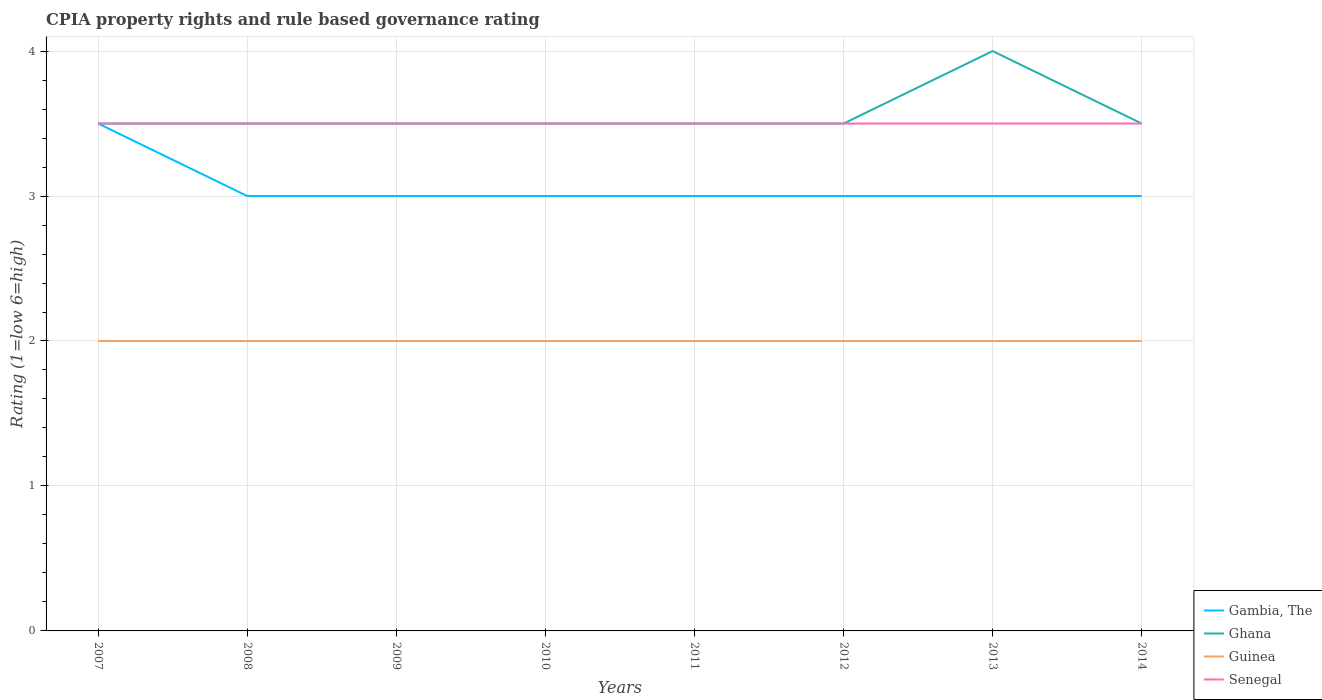How many different coloured lines are there?
Make the answer very short. 4. Is the number of lines equal to the number of legend labels?
Give a very brief answer. Yes. In which year was the CPIA rating in Ghana maximum?
Provide a short and direct response. 2007. What is the total CPIA rating in Gambia, The in the graph?
Provide a succinct answer. 0.5. What is the difference between the highest and the lowest CPIA rating in Guinea?
Offer a very short reply. 0. Is the CPIA rating in Senegal strictly greater than the CPIA rating in Ghana over the years?
Provide a short and direct response. No. How many lines are there?
Offer a terse response. 4. How many years are there in the graph?
Provide a short and direct response. 8. How are the legend labels stacked?
Provide a succinct answer. Vertical. What is the title of the graph?
Provide a succinct answer. CPIA property rights and rule based governance rating. Does "Montenegro" appear as one of the legend labels in the graph?
Offer a terse response. No. What is the label or title of the X-axis?
Your response must be concise. Years. What is the Rating (1=low 6=high) of Ghana in 2007?
Provide a short and direct response. 3.5. What is the Rating (1=low 6=high) in Guinea in 2007?
Provide a short and direct response. 2. What is the Rating (1=low 6=high) in Senegal in 2007?
Ensure brevity in your answer.  3.5. What is the Rating (1=low 6=high) of Gambia, The in 2008?
Your answer should be compact. 3. What is the Rating (1=low 6=high) of Ghana in 2008?
Your response must be concise. 3.5. What is the Rating (1=low 6=high) of Guinea in 2008?
Provide a succinct answer. 2. What is the Rating (1=low 6=high) in Gambia, The in 2009?
Your answer should be very brief. 3. What is the Rating (1=low 6=high) in Senegal in 2009?
Offer a very short reply. 3.5. What is the Rating (1=low 6=high) in Gambia, The in 2010?
Offer a terse response. 3. What is the Rating (1=low 6=high) in Guinea in 2010?
Make the answer very short. 2. What is the Rating (1=low 6=high) of Senegal in 2010?
Provide a succinct answer. 3.5. What is the Rating (1=low 6=high) of Ghana in 2011?
Your answer should be very brief. 3.5. What is the Rating (1=low 6=high) in Guinea in 2011?
Give a very brief answer. 2. What is the Rating (1=low 6=high) in Senegal in 2011?
Offer a terse response. 3.5. What is the Rating (1=low 6=high) in Gambia, The in 2012?
Offer a very short reply. 3. What is the Rating (1=low 6=high) of Senegal in 2012?
Your response must be concise. 3.5. What is the Rating (1=low 6=high) of Gambia, The in 2013?
Ensure brevity in your answer.  3. What is the Rating (1=low 6=high) in Ghana in 2014?
Ensure brevity in your answer.  3.5. Across all years, what is the maximum Rating (1=low 6=high) of Gambia, The?
Keep it short and to the point. 3.5. Across all years, what is the maximum Rating (1=low 6=high) of Ghana?
Your answer should be very brief. 4. Across all years, what is the maximum Rating (1=low 6=high) in Guinea?
Offer a very short reply. 2. Across all years, what is the minimum Rating (1=low 6=high) in Gambia, The?
Your answer should be very brief. 3. Across all years, what is the minimum Rating (1=low 6=high) of Ghana?
Give a very brief answer. 3.5. Across all years, what is the minimum Rating (1=low 6=high) in Senegal?
Your answer should be compact. 3.5. What is the total Rating (1=low 6=high) in Ghana in the graph?
Provide a short and direct response. 28.5. What is the difference between the Rating (1=low 6=high) in Ghana in 2007 and that in 2008?
Provide a succinct answer. 0. What is the difference between the Rating (1=low 6=high) in Senegal in 2007 and that in 2008?
Offer a terse response. 0. What is the difference between the Rating (1=low 6=high) in Senegal in 2007 and that in 2009?
Provide a succinct answer. 0. What is the difference between the Rating (1=low 6=high) of Gambia, The in 2007 and that in 2010?
Provide a short and direct response. 0.5. What is the difference between the Rating (1=low 6=high) of Guinea in 2007 and that in 2010?
Keep it short and to the point. 0. What is the difference between the Rating (1=low 6=high) of Guinea in 2007 and that in 2011?
Your answer should be very brief. 0. What is the difference between the Rating (1=low 6=high) in Gambia, The in 2007 and that in 2012?
Your answer should be compact. 0.5. What is the difference between the Rating (1=low 6=high) in Ghana in 2007 and that in 2012?
Provide a short and direct response. 0. What is the difference between the Rating (1=low 6=high) in Senegal in 2007 and that in 2012?
Make the answer very short. 0. What is the difference between the Rating (1=low 6=high) of Gambia, The in 2007 and that in 2013?
Give a very brief answer. 0.5. What is the difference between the Rating (1=low 6=high) in Guinea in 2007 and that in 2013?
Give a very brief answer. 0. What is the difference between the Rating (1=low 6=high) in Guinea in 2007 and that in 2014?
Provide a short and direct response. 0. What is the difference between the Rating (1=low 6=high) in Gambia, The in 2008 and that in 2011?
Offer a terse response. 0. What is the difference between the Rating (1=low 6=high) in Guinea in 2008 and that in 2011?
Provide a short and direct response. 0. What is the difference between the Rating (1=low 6=high) in Gambia, The in 2008 and that in 2013?
Keep it short and to the point. 0. What is the difference between the Rating (1=low 6=high) of Ghana in 2008 and that in 2013?
Your answer should be very brief. -0.5. What is the difference between the Rating (1=low 6=high) in Ghana in 2008 and that in 2014?
Offer a very short reply. 0. What is the difference between the Rating (1=low 6=high) of Senegal in 2008 and that in 2014?
Make the answer very short. 0. What is the difference between the Rating (1=low 6=high) of Senegal in 2009 and that in 2010?
Make the answer very short. 0. What is the difference between the Rating (1=low 6=high) of Gambia, The in 2009 and that in 2011?
Your response must be concise. 0. What is the difference between the Rating (1=low 6=high) in Guinea in 2009 and that in 2011?
Your response must be concise. 0. What is the difference between the Rating (1=low 6=high) of Senegal in 2009 and that in 2011?
Give a very brief answer. 0. What is the difference between the Rating (1=low 6=high) of Ghana in 2009 and that in 2012?
Offer a very short reply. 0. What is the difference between the Rating (1=low 6=high) in Guinea in 2009 and that in 2012?
Your response must be concise. 0. What is the difference between the Rating (1=low 6=high) of Senegal in 2009 and that in 2012?
Make the answer very short. 0. What is the difference between the Rating (1=low 6=high) of Ghana in 2009 and that in 2013?
Ensure brevity in your answer.  -0.5. What is the difference between the Rating (1=low 6=high) in Guinea in 2009 and that in 2013?
Your answer should be compact. 0. What is the difference between the Rating (1=low 6=high) in Gambia, The in 2009 and that in 2014?
Your answer should be very brief. 0. What is the difference between the Rating (1=low 6=high) of Ghana in 2009 and that in 2014?
Give a very brief answer. 0. What is the difference between the Rating (1=low 6=high) of Guinea in 2009 and that in 2014?
Make the answer very short. 0. What is the difference between the Rating (1=low 6=high) of Ghana in 2010 and that in 2011?
Provide a short and direct response. 0. What is the difference between the Rating (1=low 6=high) of Guinea in 2010 and that in 2011?
Your answer should be compact. 0. What is the difference between the Rating (1=low 6=high) of Gambia, The in 2010 and that in 2012?
Provide a succinct answer. 0. What is the difference between the Rating (1=low 6=high) of Gambia, The in 2010 and that in 2013?
Give a very brief answer. 0. What is the difference between the Rating (1=low 6=high) in Ghana in 2010 and that in 2014?
Your answer should be compact. 0. What is the difference between the Rating (1=low 6=high) of Gambia, The in 2011 and that in 2012?
Provide a succinct answer. 0. What is the difference between the Rating (1=low 6=high) of Ghana in 2011 and that in 2012?
Your answer should be compact. 0. What is the difference between the Rating (1=low 6=high) of Senegal in 2011 and that in 2012?
Offer a terse response. 0. What is the difference between the Rating (1=low 6=high) in Ghana in 2011 and that in 2013?
Provide a succinct answer. -0.5. What is the difference between the Rating (1=low 6=high) of Guinea in 2011 and that in 2013?
Offer a very short reply. 0. What is the difference between the Rating (1=low 6=high) of Ghana in 2011 and that in 2014?
Give a very brief answer. 0. What is the difference between the Rating (1=low 6=high) of Senegal in 2011 and that in 2014?
Offer a very short reply. 0. What is the difference between the Rating (1=low 6=high) of Ghana in 2012 and that in 2013?
Your response must be concise. -0.5. What is the difference between the Rating (1=low 6=high) of Guinea in 2012 and that in 2013?
Provide a short and direct response. 0. What is the difference between the Rating (1=low 6=high) in Gambia, The in 2012 and that in 2014?
Provide a succinct answer. 0. What is the difference between the Rating (1=low 6=high) of Ghana in 2012 and that in 2014?
Your answer should be compact. 0. What is the difference between the Rating (1=low 6=high) in Senegal in 2012 and that in 2014?
Give a very brief answer. 0. What is the difference between the Rating (1=low 6=high) of Ghana in 2013 and that in 2014?
Offer a very short reply. 0.5. What is the difference between the Rating (1=low 6=high) of Guinea in 2013 and that in 2014?
Your answer should be very brief. 0. What is the difference between the Rating (1=low 6=high) of Gambia, The in 2007 and the Rating (1=low 6=high) of Ghana in 2008?
Give a very brief answer. 0. What is the difference between the Rating (1=low 6=high) in Gambia, The in 2007 and the Rating (1=low 6=high) in Guinea in 2008?
Give a very brief answer. 1.5. What is the difference between the Rating (1=low 6=high) of Ghana in 2007 and the Rating (1=low 6=high) of Guinea in 2008?
Give a very brief answer. 1.5. What is the difference between the Rating (1=low 6=high) in Ghana in 2007 and the Rating (1=low 6=high) in Senegal in 2008?
Offer a very short reply. 0. What is the difference between the Rating (1=low 6=high) in Guinea in 2007 and the Rating (1=low 6=high) in Senegal in 2008?
Provide a succinct answer. -1.5. What is the difference between the Rating (1=low 6=high) in Gambia, The in 2007 and the Rating (1=low 6=high) in Guinea in 2009?
Ensure brevity in your answer.  1.5. What is the difference between the Rating (1=low 6=high) in Ghana in 2007 and the Rating (1=low 6=high) in Guinea in 2009?
Make the answer very short. 1.5. What is the difference between the Rating (1=low 6=high) in Guinea in 2007 and the Rating (1=low 6=high) in Senegal in 2009?
Provide a short and direct response. -1.5. What is the difference between the Rating (1=low 6=high) in Gambia, The in 2007 and the Rating (1=low 6=high) in Ghana in 2010?
Your answer should be compact. 0. What is the difference between the Rating (1=low 6=high) of Gambia, The in 2007 and the Rating (1=low 6=high) of Senegal in 2010?
Give a very brief answer. 0. What is the difference between the Rating (1=low 6=high) of Ghana in 2007 and the Rating (1=low 6=high) of Senegal in 2010?
Make the answer very short. 0. What is the difference between the Rating (1=low 6=high) in Gambia, The in 2007 and the Rating (1=low 6=high) in Guinea in 2011?
Provide a succinct answer. 1.5. What is the difference between the Rating (1=low 6=high) in Ghana in 2007 and the Rating (1=low 6=high) in Guinea in 2011?
Offer a terse response. 1.5. What is the difference between the Rating (1=low 6=high) of Ghana in 2007 and the Rating (1=low 6=high) of Senegal in 2012?
Give a very brief answer. 0. What is the difference between the Rating (1=low 6=high) in Gambia, The in 2007 and the Rating (1=low 6=high) in Ghana in 2013?
Offer a terse response. -0.5. What is the difference between the Rating (1=low 6=high) of Gambia, The in 2007 and the Rating (1=low 6=high) of Guinea in 2013?
Your response must be concise. 1.5. What is the difference between the Rating (1=low 6=high) of Gambia, The in 2007 and the Rating (1=low 6=high) of Senegal in 2013?
Offer a very short reply. 0. What is the difference between the Rating (1=low 6=high) in Ghana in 2007 and the Rating (1=low 6=high) in Senegal in 2013?
Give a very brief answer. 0. What is the difference between the Rating (1=low 6=high) of Guinea in 2007 and the Rating (1=low 6=high) of Senegal in 2013?
Provide a succinct answer. -1.5. What is the difference between the Rating (1=low 6=high) of Gambia, The in 2007 and the Rating (1=low 6=high) of Ghana in 2014?
Offer a terse response. 0. What is the difference between the Rating (1=low 6=high) of Gambia, The in 2007 and the Rating (1=low 6=high) of Senegal in 2014?
Make the answer very short. 0. What is the difference between the Rating (1=low 6=high) in Ghana in 2007 and the Rating (1=low 6=high) in Senegal in 2014?
Your response must be concise. 0. What is the difference between the Rating (1=low 6=high) in Gambia, The in 2008 and the Rating (1=low 6=high) in Guinea in 2009?
Your answer should be very brief. 1. What is the difference between the Rating (1=low 6=high) in Ghana in 2008 and the Rating (1=low 6=high) in Guinea in 2009?
Provide a succinct answer. 1.5. What is the difference between the Rating (1=low 6=high) in Guinea in 2008 and the Rating (1=low 6=high) in Senegal in 2009?
Make the answer very short. -1.5. What is the difference between the Rating (1=low 6=high) in Gambia, The in 2008 and the Rating (1=low 6=high) in Guinea in 2010?
Ensure brevity in your answer.  1. What is the difference between the Rating (1=low 6=high) in Gambia, The in 2008 and the Rating (1=low 6=high) in Senegal in 2010?
Give a very brief answer. -0.5. What is the difference between the Rating (1=low 6=high) in Ghana in 2008 and the Rating (1=low 6=high) in Senegal in 2010?
Make the answer very short. 0. What is the difference between the Rating (1=low 6=high) of Guinea in 2008 and the Rating (1=low 6=high) of Senegal in 2010?
Make the answer very short. -1.5. What is the difference between the Rating (1=low 6=high) of Gambia, The in 2008 and the Rating (1=low 6=high) of Ghana in 2011?
Provide a short and direct response. -0.5. What is the difference between the Rating (1=low 6=high) in Gambia, The in 2008 and the Rating (1=low 6=high) in Guinea in 2011?
Give a very brief answer. 1. What is the difference between the Rating (1=low 6=high) of Guinea in 2008 and the Rating (1=low 6=high) of Senegal in 2011?
Make the answer very short. -1.5. What is the difference between the Rating (1=low 6=high) in Gambia, The in 2008 and the Rating (1=low 6=high) in Ghana in 2012?
Your answer should be compact. -0.5. What is the difference between the Rating (1=low 6=high) of Ghana in 2008 and the Rating (1=low 6=high) of Guinea in 2012?
Keep it short and to the point. 1.5. What is the difference between the Rating (1=low 6=high) of Gambia, The in 2008 and the Rating (1=low 6=high) of Ghana in 2013?
Give a very brief answer. -1. What is the difference between the Rating (1=low 6=high) in Gambia, The in 2008 and the Rating (1=low 6=high) in Senegal in 2013?
Ensure brevity in your answer.  -0.5. What is the difference between the Rating (1=low 6=high) of Gambia, The in 2008 and the Rating (1=low 6=high) of Guinea in 2014?
Your response must be concise. 1. What is the difference between the Rating (1=low 6=high) of Gambia, The in 2008 and the Rating (1=low 6=high) of Senegal in 2014?
Your response must be concise. -0.5. What is the difference between the Rating (1=low 6=high) in Ghana in 2008 and the Rating (1=low 6=high) in Senegal in 2014?
Provide a succinct answer. 0. What is the difference between the Rating (1=low 6=high) of Gambia, The in 2009 and the Rating (1=low 6=high) of Ghana in 2010?
Your answer should be very brief. -0.5. What is the difference between the Rating (1=low 6=high) of Gambia, The in 2009 and the Rating (1=low 6=high) of Senegal in 2010?
Your answer should be very brief. -0.5. What is the difference between the Rating (1=low 6=high) of Gambia, The in 2009 and the Rating (1=low 6=high) of Ghana in 2011?
Give a very brief answer. -0.5. What is the difference between the Rating (1=low 6=high) of Gambia, The in 2009 and the Rating (1=low 6=high) of Guinea in 2011?
Offer a terse response. 1. What is the difference between the Rating (1=low 6=high) of Ghana in 2009 and the Rating (1=low 6=high) of Guinea in 2011?
Your answer should be very brief. 1.5. What is the difference between the Rating (1=low 6=high) in Ghana in 2009 and the Rating (1=low 6=high) in Senegal in 2011?
Make the answer very short. 0. What is the difference between the Rating (1=low 6=high) in Gambia, The in 2009 and the Rating (1=low 6=high) in Ghana in 2012?
Offer a terse response. -0.5. What is the difference between the Rating (1=low 6=high) of Gambia, The in 2009 and the Rating (1=low 6=high) of Guinea in 2012?
Provide a succinct answer. 1. What is the difference between the Rating (1=low 6=high) of Gambia, The in 2009 and the Rating (1=low 6=high) of Senegal in 2012?
Your answer should be very brief. -0.5. What is the difference between the Rating (1=low 6=high) in Ghana in 2009 and the Rating (1=low 6=high) in Guinea in 2012?
Provide a succinct answer. 1.5. What is the difference between the Rating (1=low 6=high) of Ghana in 2009 and the Rating (1=low 6=high) of Senegal in 2012?
Provide a short and direct response. 0. What is the difference between the Rating (1=low 6=high) in Guinea in 2009 and the Rating (1=low 6=high) in Senegal in 2012?
Offer a terse response. -1.5. What is the difference between the Rating (1=low 6=high) in Ghana in 2009 and the Rating (1=low 6=high) in Senegal in 2013?
Provide a short and direct response. 0. What is the difference between the Rating (1=low 6=high) of Guinea in 2009 and the Rating (1=low 6=high) of Senegal in 2013?
Your answer should be compact. -1.5. What is the difference between the Rating (1=low 6=high) in Gambia, The in 2009 and the Rating (1=low 6=high) in Ghana in 2014?
Provide a short and direct response. -0.5. What is the difference between the Rating (1=low 6=high) of Gambia, The in 2009 and the Rating (1=low 6=high) of Guinea in 2014?
Keep it short and to the point. 1. What is the difference between the Rating (1=low 6=high) in Ghana in 2009 and the Rating (1=low 6=high) in Guinea in 2014?
Give a very brief answer. 1.5. What is the difference between the Rating (1=low 6=high) in Ghana in 2009 and the Rating (1=low 6=high) in Senegal in 2014?
Offer a terse response. 0. What is the difference between the Rating (1=low 6=high) of Guinea in 2009 and the Rating (1=low 6=high) of Senegal in 2014?
Your answer should be very brief. -1.5. What is the difference between the Rating (1=low 6=high) of Gambia, The in 2010 and the Rating (1=low 6=high) of Senegal in 2011?
Your answer should be very brief. -0.5. What is the difference between the Rating (1=low 6=high) in Guinea in 2010 and the Rating (1=low 6=high) in Senegal in 2012?
Give a very brief answer. -1.5. What is the difference between the Rating (1=low 6=high) of Gambia, The in 2010 and the Rating (1=low 6=high) of Guinea in 2013?
Your answer should be very brief. 1. What is the difference between the Rating (1=low 6=high) of Gambia, The in 2010 and the Rating (1=low 6=high) of Senegal in 2013?
Provide a succinct answer. -0.5. What is the difference between the Rating (1=low 6=high) of Ghana in 2010 and the Rating (1=low 6=high) of Guinea in 2013?
Make the answer very short. 1.5. What is the difference between the Rating (1=low 6=high) in Guinea in 2010 and the Rating (1=low 6=high) in Senegal in 2013?
Your answer should be compact. -1.5. What is the difference between the Rating (1=low 6=high) of Gambia, The in 2010 and the Rating (1=low 6=high) of Guinea in 2014?
Provide a succinct answer. 1. What is the difference between the Rating (1=low 6=high) of Ghana in 2010 and the Rating (1=low 6=high) of Guinea in 2014?
Give a very brief answer. 1.5. What is the difference between the Rating (1=low 6=high) of Guinea in 2010 and the Rating (1=low 6=high) of Senegal in 2014?
Provide a succinct answer. -1.5. What is the difference between the Rating (1=low 6=high) in Gambia, The in 2011 and the Rating (1=low 6=high) in Ghana in 2012?
Offer a very short reply. -0.5. What is the difference between the Rating (1=low 6=high) of Gambia, The in 2011 and the Rating (1=low 6=high) of Guinea in 2012?
Offer a very short reply. 1. What is the difference between the Rating (1=low 6=high) of Gambia, The in 2011 and the Rating (1=low 6=high) of Senegal in 2012?
Provide a succinct answer. -0.5. What is the difference between the Rating (1=low 6=high) in Ghana in 2011 and the Rating (1=low 6=high) in Senegal in 2012?
Offer a very short reply. 0. What is the difference between the Rating (1=low 6=high) in Guinea in 2011 and the Rating (1=low 6=high) in Senegal in 2012?
Ensure brevity in your answer.  -1.5. What is the difference between the Rating (1=low 6=high) in Gambia, The in 2011 and the Rating (1=low 6=high) in Guinea in 2013?
Provide a short and direct response. 1. What is the difference between the Rating (1=low 6=high) of Gambia, The in 2011 and the Rating (1=low 6=high) of Senegal in 2013?
Ensure brevity in your answer.  -0.5. What is the difference between the Rating (1=low 6=high) of Ghana in 2011 and the Rating (1=low 6=high) of Senegal in 2013?
Provide a short and direct response. 0. What is the difference between the Rating (1=low 6=high) in Guinea in 2011 and the Rating (1=low 6=high) in Senegal in 2013?
Offer a very short reply. -1.5. What is the difference between the Rating (1=low 6=high) of Gambia, The in 2011 and the Rating (1=low 6=high) of Ghana in 2014?
Make the answer very short. -0.5. What is the difference between the Rating (1=low 6=high) of Gambia, The in 2011 and the Rating (1=low 6=high) of Guinea in 2014?
Offer a terse response. 1. What is the difference between the Rating (1=low 6=high) in Guinea in 2011 and the Rating (1=low 6=high) in Senegal in 2014?
Your answer should be very brief. -1.5. What is the difference between the Rating (1=low 6=high) of Gambia, The in 2012 and the Rating (1=low 6=high) of Ghana in 2013?
Provide a short and direct response. -1. What is the difference between the Rating (1=low 6=high) of Gambia, The in 2012 and the Rating (1=low 6=high) of Guinea in 2013?
Provide a succinct answer. 1. What is the difference between the Rating (1=low 6=high) of Ghana in 2012 and the Rating (1=low 6=high) of Senegal in 2013?
Keep it short and to the point. 0. What is the difference between the Rating (1=low 6=high) of Guinea in 2012 and the Rating (1=low 6=high) of Senegal in 2013?
Your response must be concise. -1.5. What is the difference between the Rating (1=low 6=high) of Gambia, The in 2012 and the Rating (1=low 6=high) of Ghana in 2014?
Your response must be concise. -0.5. What is the difference between the Rating (1=low 6=high) of Gambia, The in 2012 and the Rating (1=low 6=high) of Senegal in 2014?
Provide a short and direct response. -0.5. What is the difference between the Rating (1=low 6=high) of Ghana in 2012 and the Rating (1=low 6=high) of Guinea in 2014?
Offer a terse response. 1.5. What is the difference between the Rating (1=low 6=high) of Ghana in 2012 and the Rating (1=low 6=high) of Senegal in 2014?
Offer a terse response. 0. What is the difference between the Rating (1=low 6=high) of Guinea in 2012 and the Rating (1=low 6=high) of Senegal in 2014?
Offer a very short reply. -1.5. What is the difference between the Rating (1=low 6=high) of Gambia, The in 2013 and the Rating (1=low 6=high) of Senegal in 2014?
Keep it short and to the point. -0.5. What is the difference between the Rating (1=low 6=high) in Ghana in 2013 and the Rating (1=low 6=high) in Senegal in 2014?
Offer a terse response. 0.5. What is the average Rating (1=low 6=high) of Gambia, The per year?
Provide a succinct answer. 3.06. What is the average Rating (1=low 6=high) in Ghana per year?
Ensure brevity in your answer.  3.56. What is the average Rating (1=low 6=high) in Guinea per year?
Provide a succinct answer. 2. In the year 2007, what is the difference between the Rating (1=low 6=high) of Gambia, The and Rating (1=low 6=high) of Senegal?
Your answer should be compact. 0. In the year 2008, what is the difference between the Rating (1=low 6=high) in Gambia, The and Rating (1=low 6=high) in Guinea?
Provide a succinct answer. 1. In the year 2008, what is the difference between the Rating (1=low 6=high) of Gambia, The and Rating (1=low 6=high) of Senegal?
Your answer should be compact. -0.5. In the year 2008, what is the difference between the Rating (1=low 6=high) of Ghana and Rating (1=low 6=high) of Senegal?
Your answer should be compact. 0. In the year 2008, what is the difference between the Rating (1=low 6=high) of Guinea and Rating (1=low 6=high) of Senegal?
Keep it short and to the point. -1.5. In the year 2009, what is the difference between the Rating (1=low 6=high) in Gambia, The and Rating (1=low 6=high) in Guinea?
Provide a succinct answer. 1. In the year 2009, what is the difference between the Rating (1=low 6=high) in Ghana and Rating (1=low 6=high) in Guinea?
Provide a succinct answer. 1.5. In the year 2009, what is the difference between the Rating (1=low 6=high) in Ghana and Rating (1=low 6=high) in Senegal?
Offer a terse response. 0. In the year 2010, what is the difference between the Rating (1=low 6=high) in Gambia, The and Rating (1=low 6=high) in Ghana?
Give a very brief answer. -0.5. In the year 2010, what is the difference between the Rating (1=low 6=high) of Gambia, The and Rating (1=low 6=high) of Senegal?
Your answer should be compact. -0.5. In the year 2010, what is the difference between the Rating (1=low 6=high) in Ghana and Rating (1=low 6=high) in Guinea?
Make the answer very short. 1.5. In the year 2010, what is the difference between the Rating (1=low 6=high) of Guinea and Rating (1=low 6=high) of Senegal?
Your answer should be compact. -1.5. In the year 2011, what is the difference between the Rating (1=low 6=high) in Gambia, The and Rating (1=low 6=high) in Ghana?
Your answer should be compact. -0.5. In the year 2011, what is the difference between the Rating (1=low 6=high) in Ghana and Rating (1=low 6=high) in Senegal?
Your answer should be very brief. 0. In the year 2011, what is the difference between the Rating (1=low 6=high) in Guinea and Rating (1=low 6=high) in Senegal?
Give a very brief answer. -1.5. In the year 2012, what is the difference between the Rating (1=low 6=high) of Gambia, The and Rating (1=low 6=high) of Guinea?
Your response must be concise. 1. In the year 2012, what is the difference between the Rating (1=low 6=high) in Gambia, The and Rating (1=low 6=high) in Senegal?
Provide a short and direct response. -0.5. In the year 2012, what is the difference between the Rating (1=low 6=high) in Guinea and Rating (1=low 6=high) in Senegal?
Give a very brief answer. -1.5. In the year 2013, what is the difference between the Rating (1=low 6=high) of Gambia, The and Rating (1=low 6=high) of Ghana?
Make the answer very short. -1. In the year 2013, what is the difference between the Rating (1=low 6=high) of Gambia, The and Rating (1=low 6=high) of Guinea?
Give a very brief answer. 1. In the year 2013, what is the difference between the Rating (1=low 6=high) of Ghana and Rating (1=low 6=high) of Guinea?
Provide a short and direct response. 2. In the year 2013, what is the difference between the Rating (1=low 6=high) of Guinea and Rating (1=low 6=high) of Senegal?
Your answer should be very brief. -1.5. In the year 2014, what is the difference between the Rating (1=low 6=high) of Gambia, The and Rating (1=low 6=high) of Guinea?
Provide a succinct answer. 1. In the year 2014, what is the difference between the Rating (1=low 6=high) of Ghana and Rating (1=low 6=high) of Guinea?
Offer a terse response. 1.5. In the year 2014, what is the difference between the Rating (1=low 6=high) of Ghana and Rating (1=low 6=high) of Senegal?
Make the answer very short. 0. What is the ratio of the Rating (1=low 6=high) in Gambia, The in 2007 to that in 2008?
Ensure brevity in your answer.  1.17. What is the ratio of the Rating (1=low 6=high) in Ghana in 2007 to that in 2008?
Your response must be concise. 1. What is the ratio of the Rating (1=low 6=high) in Guinea in 2007 to that in 2008?
Keep it short and to the point. 1. What is the ratio of the Rating (1=low 6=high) of Ghana in 2007 to that in 2009?
Give a very brief answer. 1. What is the ratio of the Rating (1=low 6=high) of Senegal in 2007 to that in 2009?
Keep it short and to the point. 1. What is the ratio of the Rating (1=low 6=high) in Ghana in 2007 to that in 2011?
Offer a very short reply. 1. What is the ratio of the Rating (1=low 6=high) of Guinea in 2007 to that in 2011?
Make the answer very short. 1. What is the ratio of the Rating (1=low 6=high) in Senegal in 2007 to that in 2011?
Ensure brevity in your answer.  1. What is the ratio of the Rating (1=low 6=high) in Senegal in 2007 to that in 2012?
Give a very brief answer. 1. What is the ratio of the Rating (1=low 6=high) of Gambia, The in 2007 to that in 2014?
Keep it short and to the point. 1.17. What is the ratio of the Rating (1=low 6=high) of Ghana in 2007 to that in 2014?
Offer a terse response. 1. What is the ratio of the Rating (1=low 6=high) of Guinea in 2007 to that in 2014?
Provide a succinct answer. 1. What is the ratio of the Rating (1=low 6=high) of Senegal in 2007 to that in 2014?
Keep it short and to the point. 1. What is the ratio of the Rating (1=low 6=high) in Ghana in 2008 to that in 2009?
Provide a short and direct response. 1. What is the ratio of the Rating (1=low 6=high) of Guinea in 2008 to that in 2009?
Your response must be concise. 1. What is the ratio of the Rating (1=low 6=high) in Senegal in 2008 to that in 2009?
Provide a succinct answer. 1. What is the ratio of the Rating (1=low 6=high) in Ghana in 2008 to that in 2010?
Offer a very short reply. 1. What is the ratio of the Rating (1=low 6=high) in Guinea in 2008 to that in 2010?
Make the answer very short. 1. What is the ratio of the Rating (1=low 6=high) in Senegal in 2008 to that in 2010?
Provide a short and direct response. 1. What is the ratio of the Rating (1=low 6=high) in Gambia, The in 2008 to that in 2011?
Offer a terse response. 1. What is the ratio of the Rating (1=low 6=high) in Ghana in 2008 to that in 2012?
Give a very brief answer. 1. What is the ratio of the Rating (1=low 6=high) in Gambia, The in 2008 to that in 2013?
Give a very brief answer. 1. What is the ratio of the Rating (1=low 6=high) in Ghana in 2008 to that in 2013?
Offer a terse response. 0.88. What is the ratio of the Rating (1=low 6=high) in Guinea in 2008 to that in 2013?
Ensure brevity in your answer.  1. What is the ratio of the Rating (1=low 6=high) in Gambia, The in 2008 to that in 2014?
Provide a succinct answer. 1. What is the ratio of the Rating (1=low 6=high) in Guinea in 2008 to that in 2014?
Give a very brief answer. 1. What is the ratio of the Rating (1=low 6=high) in Senegal in 2008 to that in 2014?
Provide a short and direct response. 1. What is the ratio of the Rating (1=low 6=high) in Gambia, The in 2009 to that in 2010?
Your response must be concise. 1. What is the ratio of the Rating (1=low 6=high) in Ghana in 2009 to that in 2010?
Give a very brief answer. 1. What is the ratio of the Rating (1=low 6=high) in Guinea in 2009 to that in 2010?
Give a very brief answer. 1. What is the ratio of the Rating (1=low 6=high) of Gambia, The in 2009 to that in 2011?
Your answer should be very brief. 1. What is the ratio of the Rating (1=low 6=high) of Ghana in 2009 to that in 2011?
Offer a very short reply. 1. What is the ratio of the Rating (1=low 6=high) of Guinea in 2009 to that in 2011?
Your response must be concise. 1. What is the ratio of the Rating (1=low 6=high) of Senegal in 2009 to that in 2011?
Make the answer very short. 1. What is the ratio of the Rating (1=low 6=high) of Gambia, The in 2009 to that in 2012?
Ensure brevity in your answer.  1. What is the ratio of the Rating (1=low 6=high) in Guinea in 2009 to that in 2013?
Provide a succinct answer. 1. What is the ratio of the Rating (1=low 6=high) of Senegal in 2009 to that in 2013?
Your answer should be compact. 1. What is the ratio of the Rating (1=low 6=high) of Ghana in 2009 to that in 2014?
Your response must be concise. 1. What is the ratio of the Rating (1=low 6=high) of Senegal in 2009 to that in 2014?
Provide a short and direct response. 1. What is the ratio of the Rating (1=low 6=high) of Gambia, The in 2010 to that in 2011?
Give a very brief answer. 1. What is the ratio of the Rating (1=low 6=high) in Senegal in 2010 to that in 2011?
Your answer should be compact. 1. What is the ratio of the Rating (1=low 6=high) in Ghana in 2010 to that in 2012?
Your answer should be very brief. 1. What is the ratio of the Rating (1=low 6=high) in Guinea in 2010 to that in 2012?
Offer a terse response. 1. What is the ratio of the Rating (1=low 6=high) of Senegal in 2010 to that in 2012?
Make the answer very short. 1. What is the ratio of the Rating (1=low 6=high) in Ghana in 2010 to that in 2013?
Offer a terse response. 0.88. What is the ratio of the Rating (1=low 6=high) in Guinea in 2010 to that in 2013?
Your answer should be compact. 1. What is the ratio of the Rating (1=low 6=high) in Ghana in 2010 to that in 2014?
Your answer should be compact. 1. What is the ratio of the Rating (1=low 6=high) of Guinea in 2010 to that in 2014?
Keep it short and to the point. 1. What is the ratio of the Rating (1=low 6=high) of Ghana in 2011 to that in 2012?
Ensure brevity in your answer.  1. What is the ratio of the Rating (1=low 6=high) of Guinea in 2011 to that in 2012?
Your answer should be very brief. 1. What is the ratio of the Rating (1=low 6=high) in Gambia, The in 2011 to that in 2013?
Give a very brief answer. 1. What is the ratio of the Rating (1=low 6=high) in Ghana in 2011 to that in 2013?
Your response must be concise. 0.88. What is the ratio of the Rating (1=low 6=high) of Guinea in 2011 to that in 2013?
Give a very brief answer. 1. What is the ratio of the Rating (1=low 6=high) of Senegal in 2011 to that in 2013?
Ensure brevity in your answer.  1. What is the ratio of the Rating (1=low 6=high) in Gambia, The in 2011 to that in 2014?
Offer a very short reply. 1. What is the ratio of the Rating (1=low 6=high) of Ghana in 2012 to that in 2013?
Give a very brief answer. 0.88. What is the ratio of the Rating (1=low 6=high) of Senegal in 2012 to that in 2013?
Give a very brief answer. 1. What is the ratio of the Rating (1=low 6=high) of Gambia, The in 2012 to that in 2014?
Your answer should be very brief. 1. What is the ratio of the Rating (1=low 6=high) of Guinea in 2012 to that in 2014?
Your answer should be very brief. 1. What is the ratio of the Rating (1=low 6=high) in Senegal in 2012 to that in 2014?
Provide a succinct answer. 1. What is the ratio of the Rating (1=low 6=high) in Ghana in 2013 to that in 2014?
Offer a terse response. 1.14. What is the ratio of the Rating (1=low 6=high) of Guinea in 2013 to that in 2014?
Make the answer very short. 1. What is the ratio of the Rating (1=low 6=high) in Senegal in 2013 to that in 2014?
Your response must be concise. 1. What is the difference between the highest and the lowest Rating (1=low 6=high) of Ghana?
Provide a short and direct response. 0.5. What is the difference between the highest and the lowest Rating (1=low 6=high) in Guinea?
Offer a very short reply. 0. 